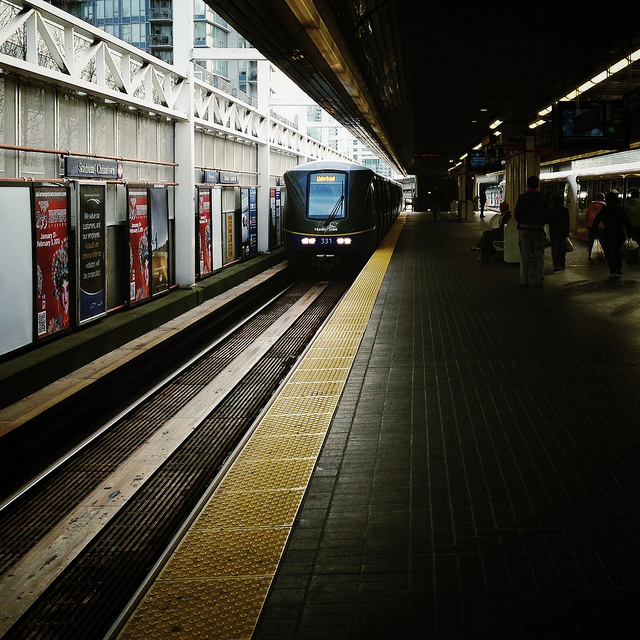Please transcribe the text in this image. 331 